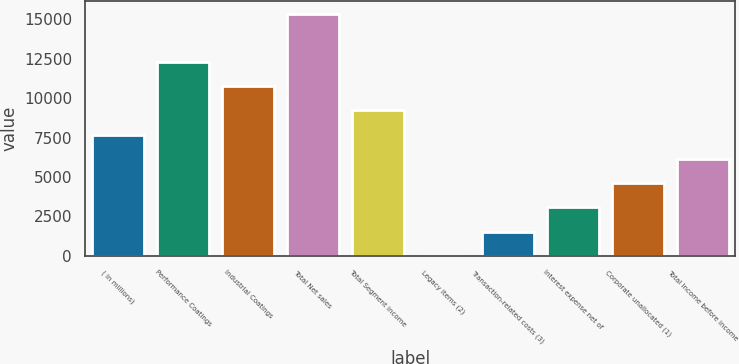Convert chart to OTSL. <chart><loc_0><loc_0><loc_500><loc_500><bar_chart><fcel>( in millions)<fcel>Performance Coatings<fcel>Industrial Coatings<fcel>Total Net sales<fcel>Total Segment income<fcel>Legacy items (2)<fcel>Transaction-related costs (3)<fcel>Interest expense net of<fcel>Corporate unallocated (1)<fcel>Total Income before income<nl><fcel>7689.5<fcel>12300.2<fcel>10763.3<fcel>15374<fcel>9226.4<fcel>5<fcel>1541.9<fcel>3078.8<fcel>4615.7<fcel>6152.6<nl></chart> 